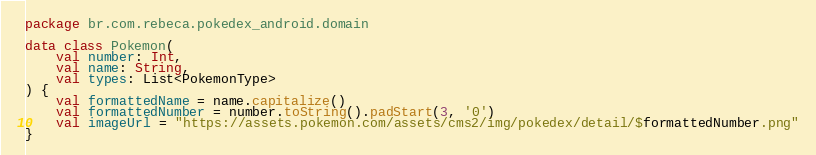<code> <loc_0><loc_0><loc_500><loc_500><_Kotlin_>package br.com.rebeca.pokedex_android.domain

data class Pokemon(
    val number: Int,
    val name: String,
    val types: List<PokemonType>
) {
    val formattedName = name.capitalize()
    val formattedNumber = number.toString().padStart(3, '0')
    val imageUrl = "https://assets.pokemon.com/assets/cms2/img/pokedex/detail/$formattedNumber.png"
}

</code> 